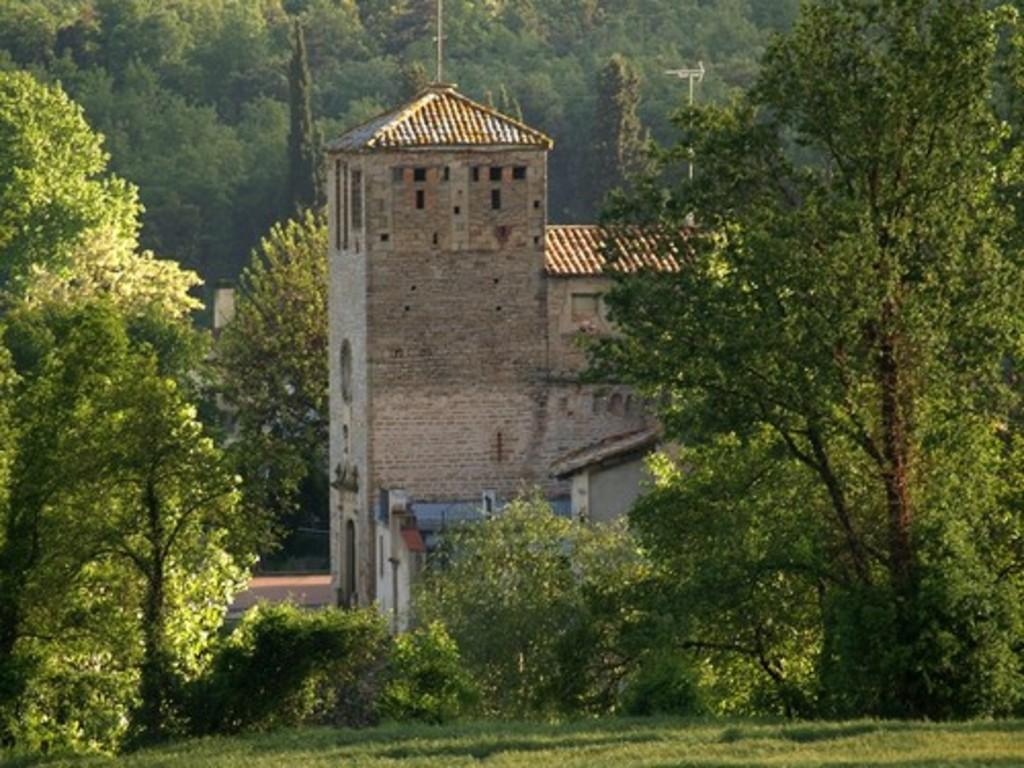What is the main subject in the center of the image? There is a building in the center of the image. What can be seen in the background of the image? There are many trees in the background of the image. What type of vegetation is at the bottom of the image? There is grass at the bottom of the image. How does the wind affect the vacation in the image? There is no vacation or wind present in the image; it only features a building, trees, and grass. 